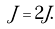Convert formula to latex. <formula><loc_0><loc_0><loc_500><loc_500>\tilde { J } = 2 J .</formula> 